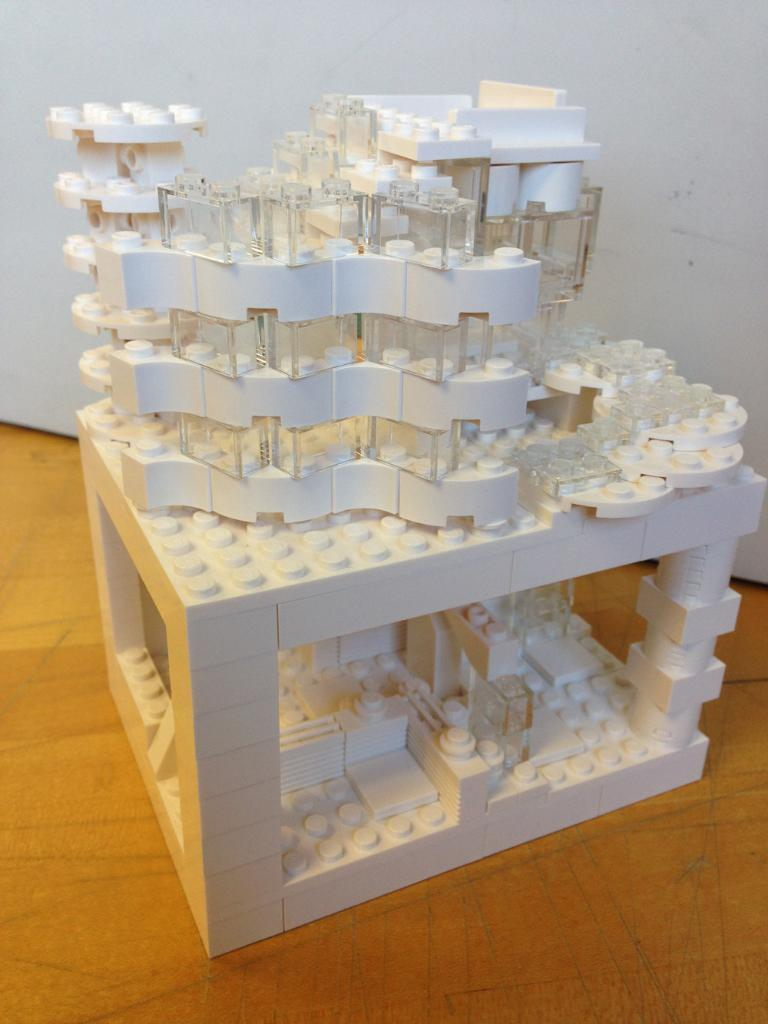What is the main subject of the image? There is a miniature building in the image. How is the miniature building displayed in the image? The miniature building is on a platform. What color is the background of the image? The background of the image is white. How many slices of bread are on the table in the image? There is no table or bread present in the image; it features a miniature building on a platform with a white background. 